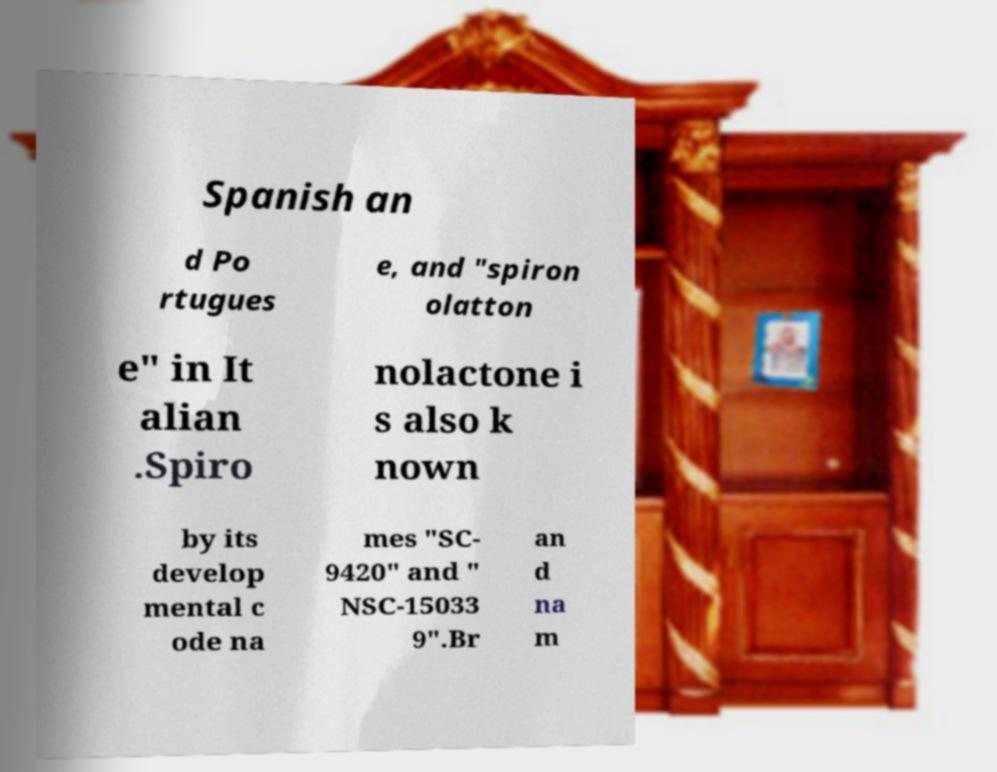Could you assist in decoding the text presented in this image and type it out clearly? Spanish an d Po rtugues e, and "spiron olatton e" in It alian .Spiro nolactone i s also k nown by its develop mental c ode na mes "SC- 9420" and " NSC-15033 9".Br an d na m 